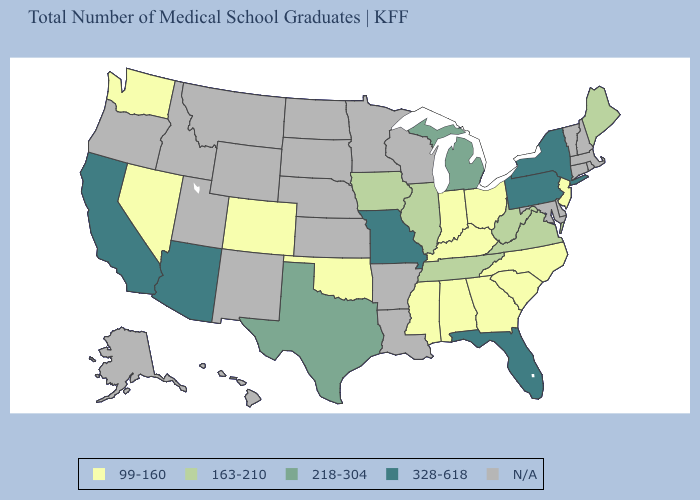What is the value of Arizona?
Quick response, please. 328-618. Does Michigan have the lowest value in the MidWest?
Concise answer only. No. Is the legend a continuous bar?
Keep it brief. No. What is the lowest value in the South?
Answer briefly. 99-160. Which states have the highest value in the USA?
Answer briefly. Arizona, California, Florida, Missouri, New York, Pennsylvania. How many symbols are there in the legend?
Answer briefly. 5. Among the states that border Arizona , which have the lowest value?
Short answer required. Colorado, Nevada. Name the states that have a value in the range 99-160?
Answer briefly. Alabama, Colorado, Georgia, Indiana, Kentucky, Mississippi, Nevada, New Jersey, North Carolina, Ohio, Oklahoma, South Carolina, Washington. What is the value of Missouri?
Be succinct. 328-618. Name the states that have a value in the range N/A?
Keep it brief. Alaska, Arkansas, Connecticut, Delaware, Hawaii, Idaho, Kansas, Louisiana, Maryland, Massachusetts, Minnesota, Montana, Nebraska, New Hampshire, New Mexico, North Dakota, Oregon, Rhode Island, South Dakota, Utah, Vermont, Wisconsin, Wyoming. What is the value of New Hampshire?
Write a very short answer. N/A. Does the first symbol in the legend represent the smallest category?
Quick response, please. Yes. Which states have the lowest value in the Northeast?
Short answer required. New Jersey. 